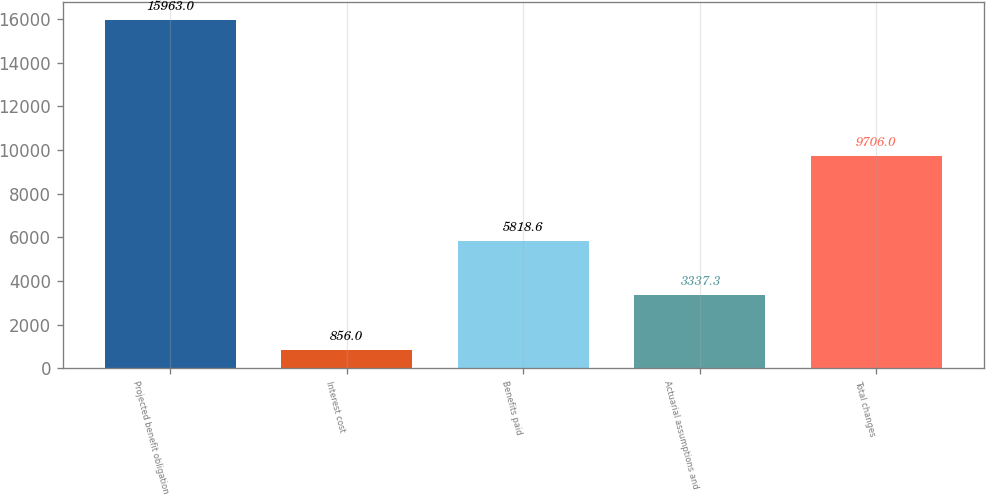<chart> <loc_0><loc_0><loc_500><loc_500><bar_chart><fcel>Projected benefit obligation<fcel>Interest cost<fcel>Benefits paid<fcel>Actuarial assumptions and<fcel>Total changes<nl><fcel>15963<fcel>856<fcel>5818.6<fcel>3337.3<fcel>9706<nl></chart> 